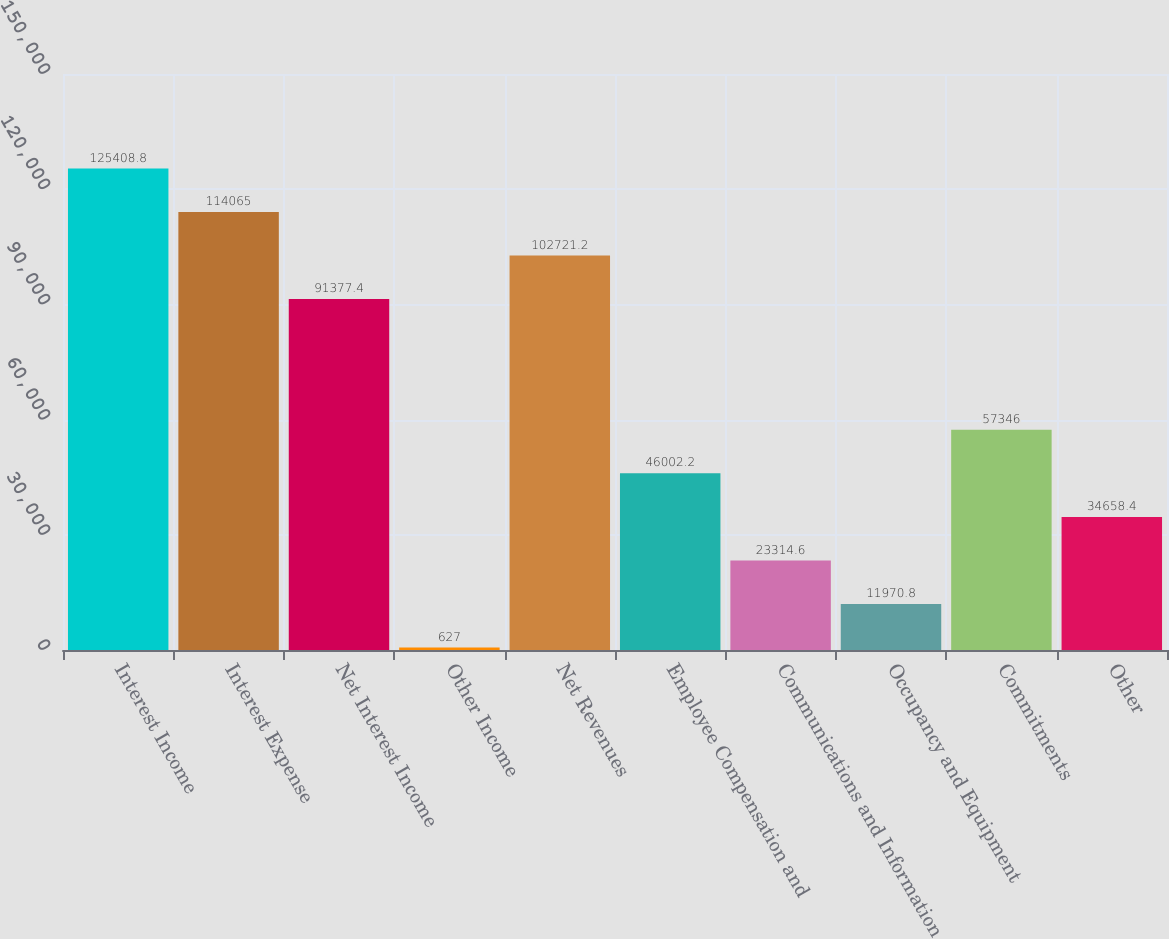<chart> <loc_0><loc_0><loc_500><loc_500><bar_chart><fcel>Interest Income<fcel>Interest Expense<fcel>Net Interest Income<fcel>Other Income<fcel>Net Revenues<fcel>Employee Compensation and<fcel>Communications and Information<fcel>Occupancy and Equipment<fcel>Commitments<fcel>Other<nl><fcel>125409<fcel>114065<fcel>91377.4<fcel>627<fcel>102721<fcel>46002.2<fcel>23314.6<fcel>11970.8<fcel>57346<fcel>34658.4<nl></chart> 